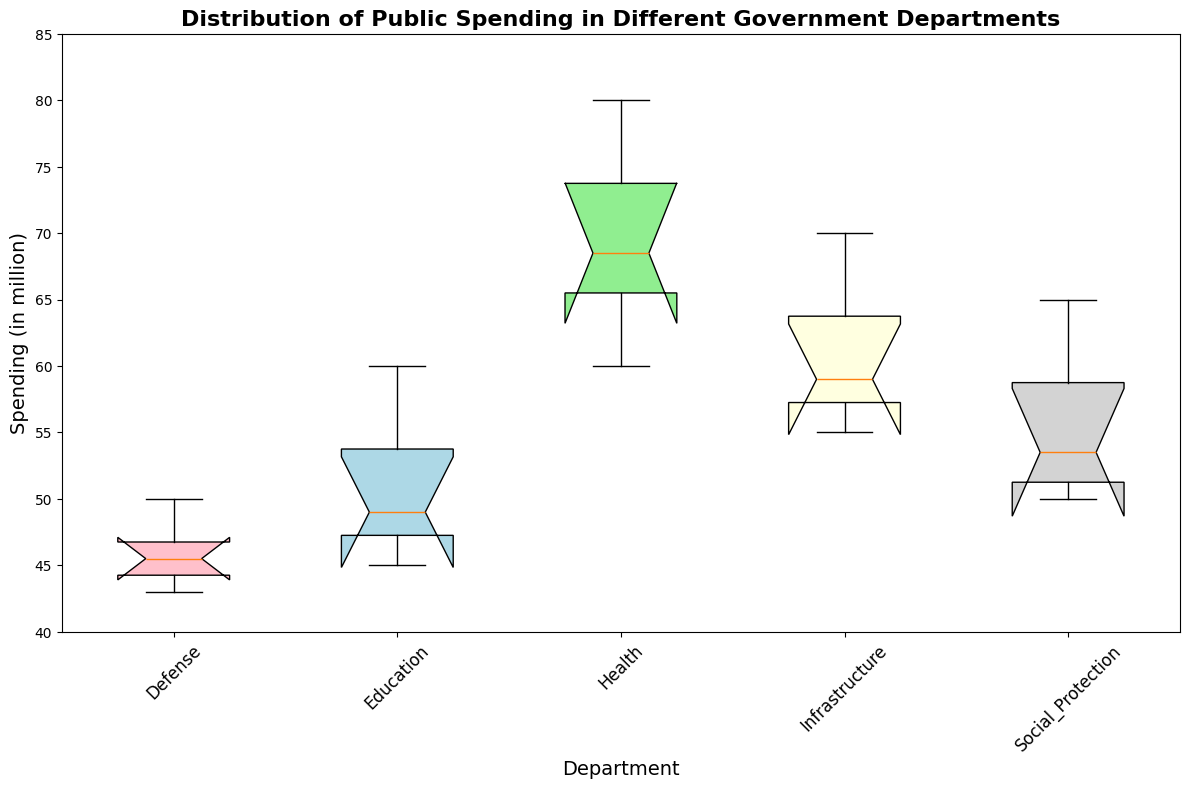What is the median spending in the Health Department? Look at the box plot for the Health Department, locate the line within the box which represents the median spending.
Answer: 67 Which department has the highest median spending? Compare the medians of all departments by looking at the line within each box. The highest line indicates the highest median spending.
Answer: Health How do the lower quartiles of the Defense and Education departments compare? Identify and compare the bottom edges of the boxes (lower quartiles) for both the Defense and Education departments.
Answer: Education's lower quartile is higher than Defense's What is the interquartile range (IQR) for the Social Protection department? Calculate the IQR by finding the difference between the upper quartile (top of the box) and the lower quartile (bottom of the box) for Social Protection.
Answer: 10 Which department shows the most variability in spending? Variability can be observed from the length of the boxes and the spread of whiskers and outliers. The department with the largest range (distance from the bottom whisker to the top whisker) has the most variability.
Answer: Health Are there any outliers in the Education Department spending? Outliers are represented by markers outside the whiskers. Check if there are any individual points outside the whiskers for the Education Department.
Answer: No Which department's median spending increased the most over the years? Look at the upward movement of the median line within the box plot over multiple years for each department. Identify the department with the highest shift in the median line.
Answer: Education How do the upper quartiles of Infrastructure and Social Protection compare? Identify and compare the top edges of the boxes (upper quartiles) for both Infrastructure and Social Protection.
Answer: Infrastructure's upper quartile is higher than Social Protection's What can you infer about the consistency of spending in the Defense department? Consistency can be inferred from the compactness of the box and whiskers. Examine how closely spaced the median, quartiles, and whiskers are.
Answer: Defense shows relatively consistent spending Which department shows the least interquartile range (IQR) in spending? Calculate the IQR for each department by finding the difference between the upper and lower quartiles and compare these values.
Answer: Defense 